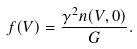Convert formula to latex. <formula><loc_0><loc_0><loc_500><loc_500>f ( V ) = \frac { \gamma ^ { 2 } n ( V , 0 ) } { G } .</formula> 